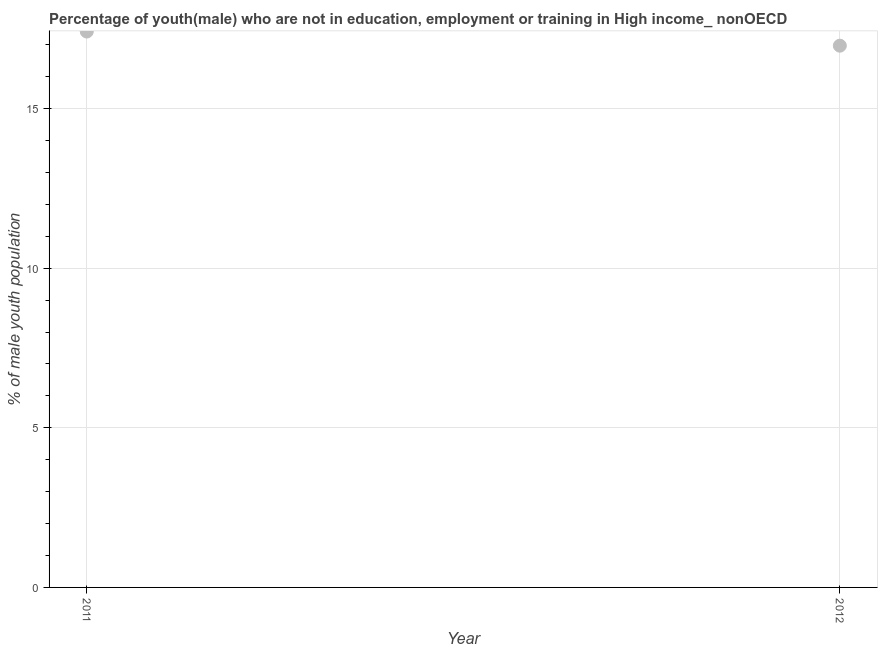What is the unemployed male youth population in 2011?
Ensure brevity in your answer.  17.42. Across all years, what is the maximum unemployed male youth population?
Your answer should be compact. 17.42. Across all years, what is the minimum unemployed male youth population?
Provide a short and direct response. 16.97. What is the sum of the unemployed male youth population?
Your answer should be compact. 34.39. What is the difference between the unemployed male youth population in 2011 and 2012?
Your answer should be compact. 0.44. What is the average unemployed male youth population per year?
Ensure brevity in your answer.  17.19. What is the median unemployed male youth population?
Your response must be concise. 17.19. Do a majority of the years between 2012 and 2011 (inclusive) have unemployed male youth population greater than 11 %?
Offer a terse response. No. What is the ratio of the unemployed male youth population in 2011 to that in 2012?
Make the answer very short. 1.03. Is the unemployed male youth population in 2011 less than that in 2012?
Offer a very short reply. No. In how many years, is the unemployed male youth population greater than the average unemployed male youth population taken over all years?
Your answer should be compact. 1. How many dotlines are there?
Make the answer very short. 1. What is the difference between two consecutive major ticks on the Y-axis?
Keep it short and to the point. 5. Does the graph contain any zero values?
Offer a terse response. No. What is the title of the graph?
Keep it short and to the point. Percentage of youth(male) who are not in education, employment or training in High income_ nonOECD. What is the label or title of the Y-axis?
Give a very brief answer. % of male youth population. What is the % of male youth population in 2011?
Your answer should be very brief. 17.42. What is the % of male youth population in 2012?
Ensure brevity in your answer.  16.97. What is the difference between the % of male youth population in 2011 and 2012?
Keep it short and to the point. 0.44. 